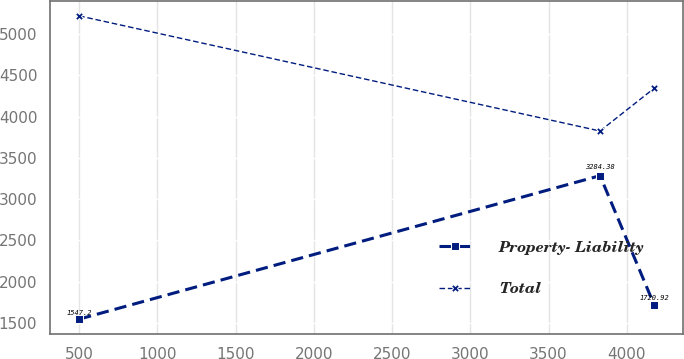Convert chart to OTSL. <chart><loc_0><loc_0><loc_500><loc_500><line_chart><ecel><fcel>Property- Liability<fcel>Total<nl><fcel>499.76<fcel>1547.2<fcel>5219.29<nl><fcel>3828.69<fcel>3284.38<fcel>3825.13<nl><fcel>4174.48<fcel>1720.92<fcel>4342<nl></chart> 